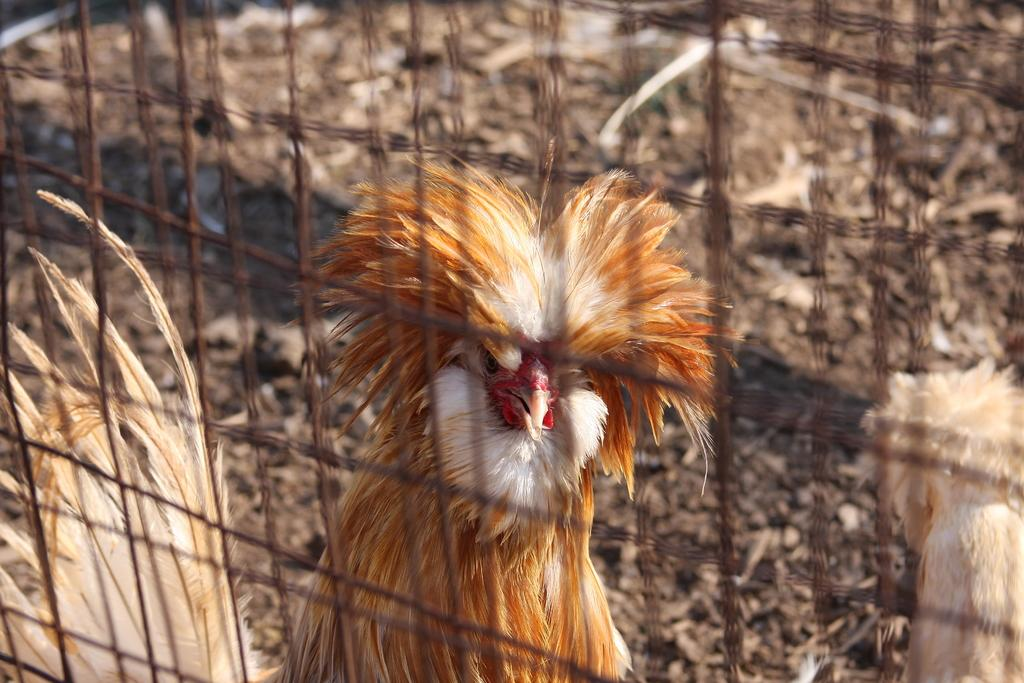What type of animal is in the picture? There is a cock in the picture. What can be seen in the foreground of the picture? There is fencing in the foreground of the picture. How would you describe the background of the picture? The background of the picture is blurred. Can you describe the animal on the right side of the picture? There is no animal mentioned on the right side of the picture; the only animal mentioned is the cock. What type of chin can be seen on the cock in the picture? There is no mention of a chin in the description of the cock in the picture. 